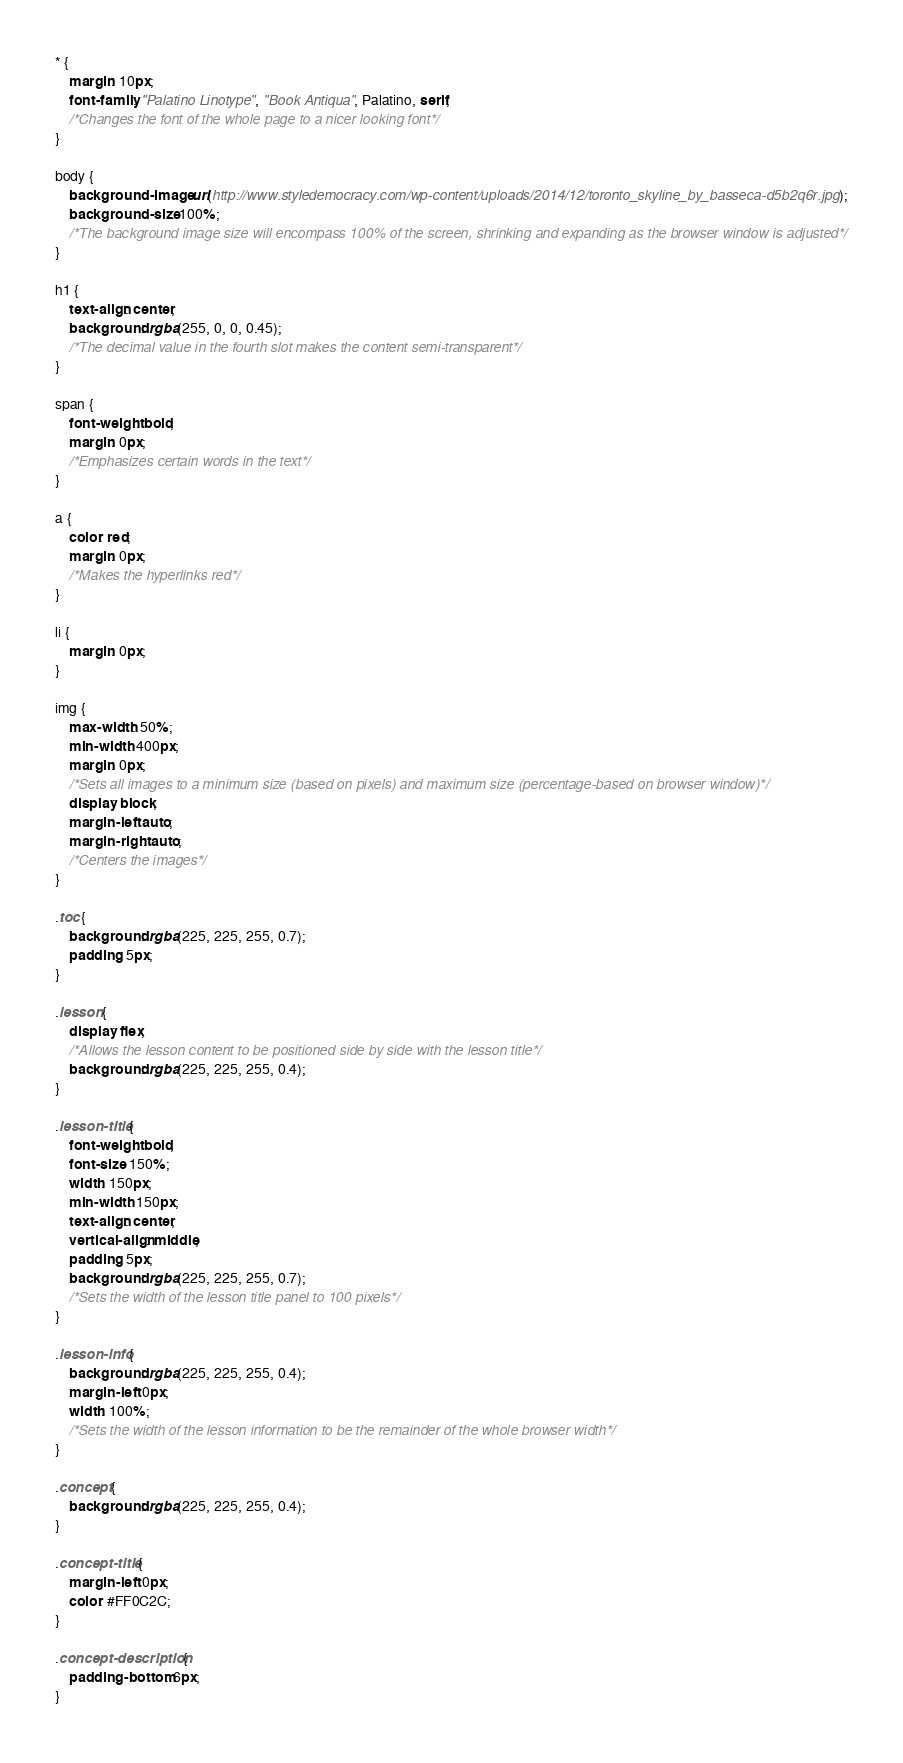Convert code to text. <code><loc_0><loc_0><loc_500><loc_500><_CSS_>* {
    margin: 10px;
    font-family: "Palatino Linotype", "Book Antiqua", Palatino, serif;
    /*Changes the font of the whole page to a nicer looking font*/
}

body {
    background-image: url(http://www.styledemocracy.com/wp-content/uploads/2014/12/toronto_skyline_by_basseca-d5b2q6r.jpg);
    background-size: 100%;
    /*The background image size will encompass 100% of the screen, shrinking and expanding as the browser window is adjusted*/
}

h1 {
    text-align: center;
    background: rgba(255, 0, 0, 0.45);
    /*The decimal value in the fourth slot makes the content semi-transparent*/
}

span {
    font-weight: bold;
    margin: 0px;
    /*Emphasizes certain words in the text*/
}

a {
    color: red;
    margin: 0px;
    /*Makes the hyperlinks red*/
}

li {
    margin: 0px;
}

img {
    max-width: 50%;
    min-width: 400px;
    margin: 0px;
    /*Sets all images to a minimum size (based on pixels) and maximum size (percentage-based on browser window)*/
    display: block;
    margin-left: auto;
    margin-right: auto;
    /*Centers the images*/
}

.toc {
    background: rgba(225, 225, 255, 0.7);
    padding: 5px;
}

.lesson {
    display: flex;
    /*Allows the lesson content to be positioned side by side with the lesson title*/
    background: rgba(225, 225, 255, 0.4);
}

.lesson-title {
    font-weight: bold;
    font-size: 150%;
    width: 150px;
    min-width: 150px;
    text-align: center;
    vertical-align: middle;
    padding: 5px;
    background: rgba(225, 225, 255, 0.7);
    /*Sets the width of the lesson title panel to 100 pixels*/
}

.lesson-info {
    background: rgba(225, 225, 255, 0.4);
    margin-left: 0px;
    width: 100%;
    /*Sets the width of the lesson information to be the remainder of the whole browser width*/
}

.concept {
    background: rgba(225, 225, 255, 0.4);
}

.concept-title {
    margin-left: 0px;
    color: #FF0C2C;
}

.concept-description {
    padding-bottom: 6px;
}
</code> 